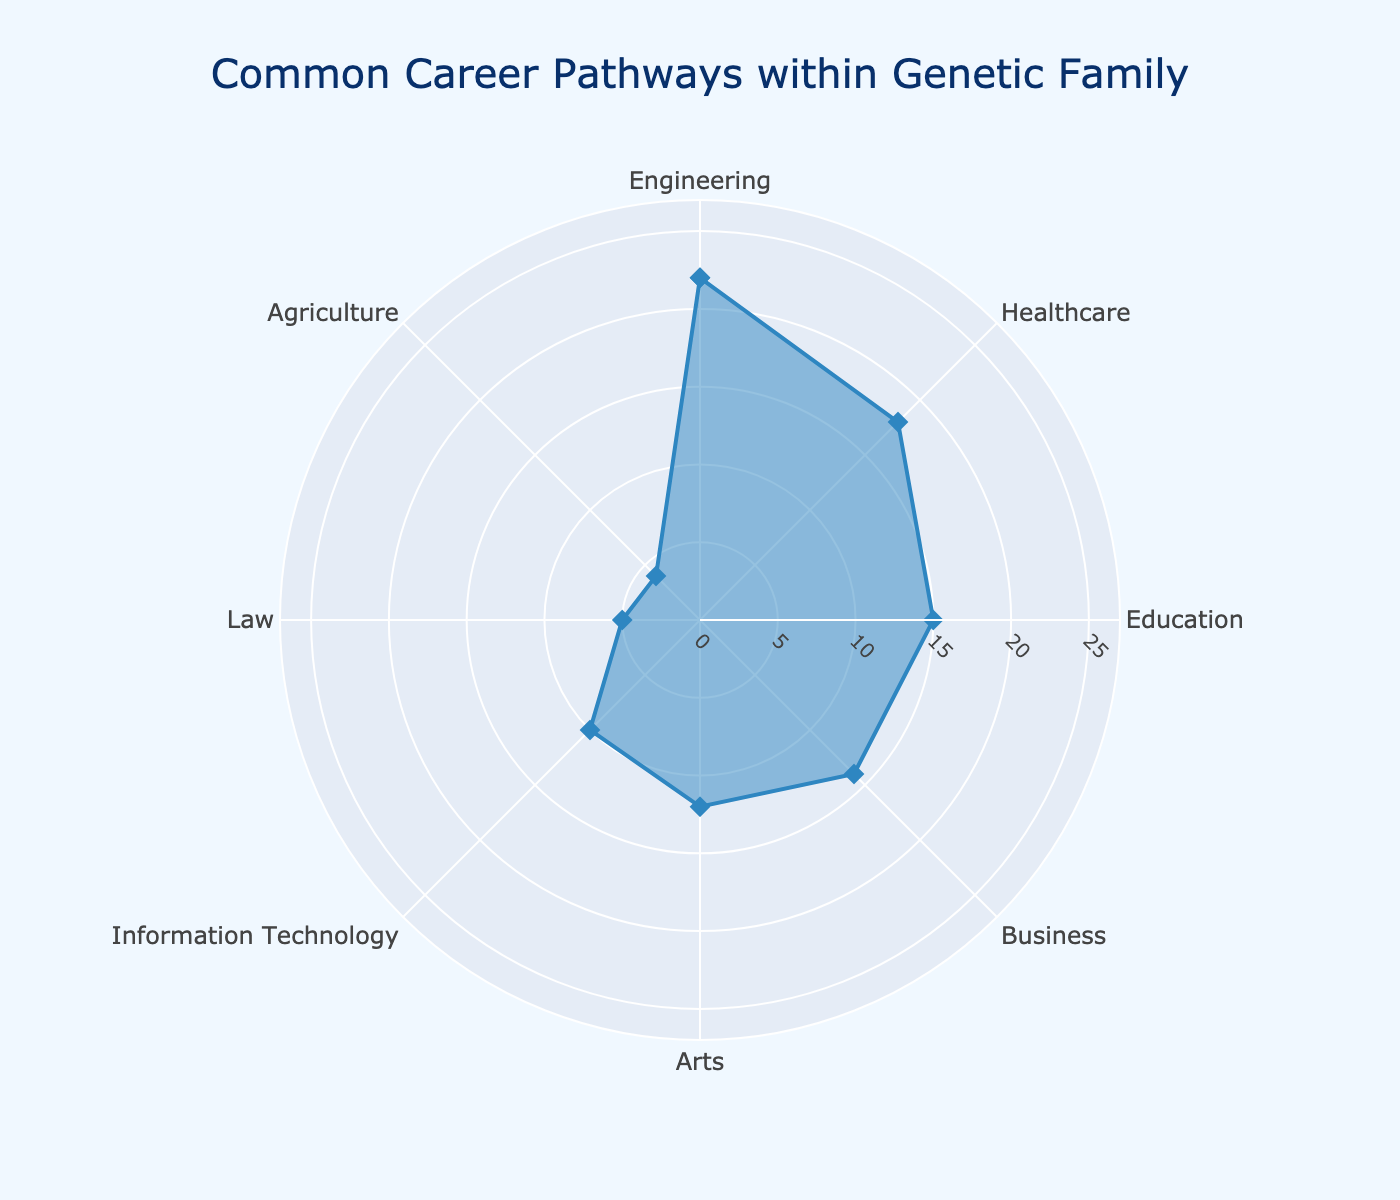what is the highest percentage category in the radar chart? The highest value in the radar chart represents the most common career pathway. By inspecting the chart, the category with the highest percentage is "Engineering" at 22%.
Answer: Engineering What is the total percentage of categories related to STEM fields (Science, Technology, Engineering, and Mathematics)? To obtain the total percentage for STEM fields, sum the values for Engineering (22), Healthcare (18), and Information Technology (10). There are 3 categories grouped for STEM. The calculation is 22 + 18 + 10 = 50.
Answer: 50 how does the percentage for Education compare to Business? To compare, subtract the percentage for Business (14) from Education (15). The difference is 15 - 14 = 1. This means Education is higher by 1%.
Answer: Education is higher by 1% What category has the lowest percentage? By looking at the radar chart, the category with the lowest percentage is Agriculture at 4%.
Answer: Agriculture How are the percentages for Law and Agriculture different? To determine the difference, subtract the percentage for Agriculture (4) from Law (5). The difference is 5 - 4 = 1. Thus, Law is 1% higher than Agriculture.
Answer: Law is 1% higher What is the range of the radial axis in the radar chart? The radar chart has a radial axis that starts at 0 and goes up to a value slightly above the highest category percentage. The range is from 0 to a bit beyond 22%, approximated to 25%.
Answer: 25 What occupations are included under 10%? Occupations lower than 10% include Law (5%) and Agriculture (4%).
Answer: Law and Agriculture What is the average percentage of all career pathways? To find the average, sum all percentages and divide by the number of categories. Total percentage = 22 + 18 + 15 + 14 + 12 + 10 + 5 + 4 = 100. Number of categories = 8. So, average = 100 / 8 = 12.5.
Answer: 12.5 Which is more common, Healthcare careers or Arts careers, and by how much? Compare percentages for Healthcare (18%) and Arts (12%). The difference is 18 - 12 = 6. Healthcare careers are 6% more common than Arts careers.
Answer: Healthcare by 6% How many data points are there in the radar chart? By inspecting the radar chart, there are 8 unique categories, indicating 8 data points.
Answer: 8 